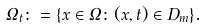<formula> <loc_0><loc_0><loc_500><loc_500>\Omega _ { t } \colon = \{ x \in \Omega \colon ( x , t ) \in D _ { m } \} .</formula> 